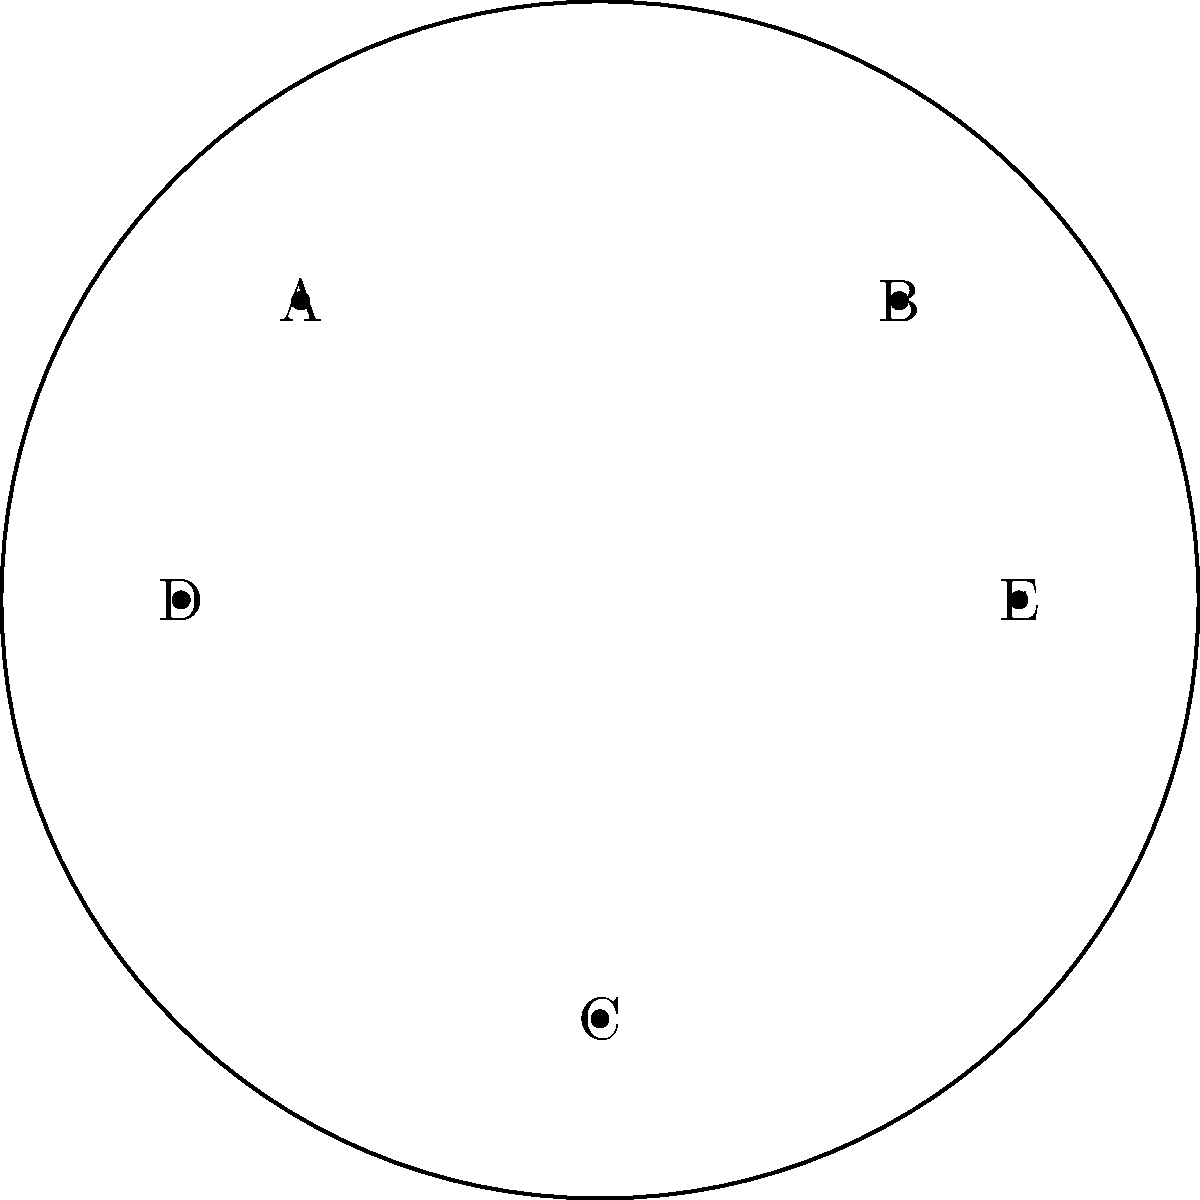In the hyperbolic geometry representation of tourist destinations shown above, how many direct connections does destination C have to other locations? To answer this question, we need to understand how hyperbolic geometry is used to represent interconnected tourist destinations in this network diagram:

1. The circular boundary represents the edge of the hyperbolic plane.
2. Each point (A, B, C, D, E) within the circle represents a tourist destination.
3. The curved lines between points represent direct connections or routes between destinations.

Now, let's analyze the connections for destination C:

1. There is a curved line connecting C to A.
2. There is a curved line connecting C to B.
3. There is a curved line connecting C to D.
4. There is a curved line connecting C to E.

By counting these connections, we can determine that destination C has 4 direct connections to other locations in this hyperbolic representation.

This hyperbolic model is particularly useful for representing complex networks of tourist destinations because:
- It allows for the efficient representation of many interconnected nodes in a limited space.
- The curvature of the lines represents the non-Euclidean nature of the connections, which can be interpreted as representing factors like travel time or difficulty between destinations.
- It provides a visually intuitive way to understand the relationships between multiple destinations simultaneously.
Answer: 4 connections 